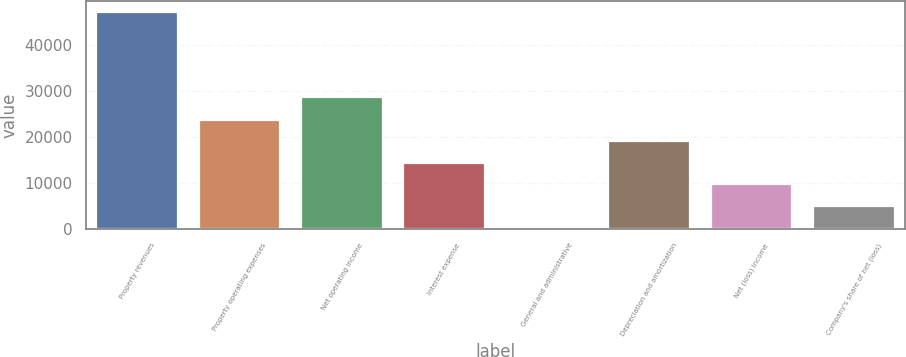Convert chart. <chart><loc_0><loc_0><loc_500><loc_500><bar_chart><fcel>Property revenues<fcel>Property operating expenses<fcel>Net operating income<fcel>Interest expense<fcel>General and administrative<fcel>Depreciation and amortization<fcel>Net (loss) income<fcel>Company's share of net (loss)<nl><fcel>47201<fcel>23747.5<fcel>28751<fcel>14366.1<fcel>294<fcel>19056.8<fcel>9675.4<fcel>4984.7<nl></chart> 